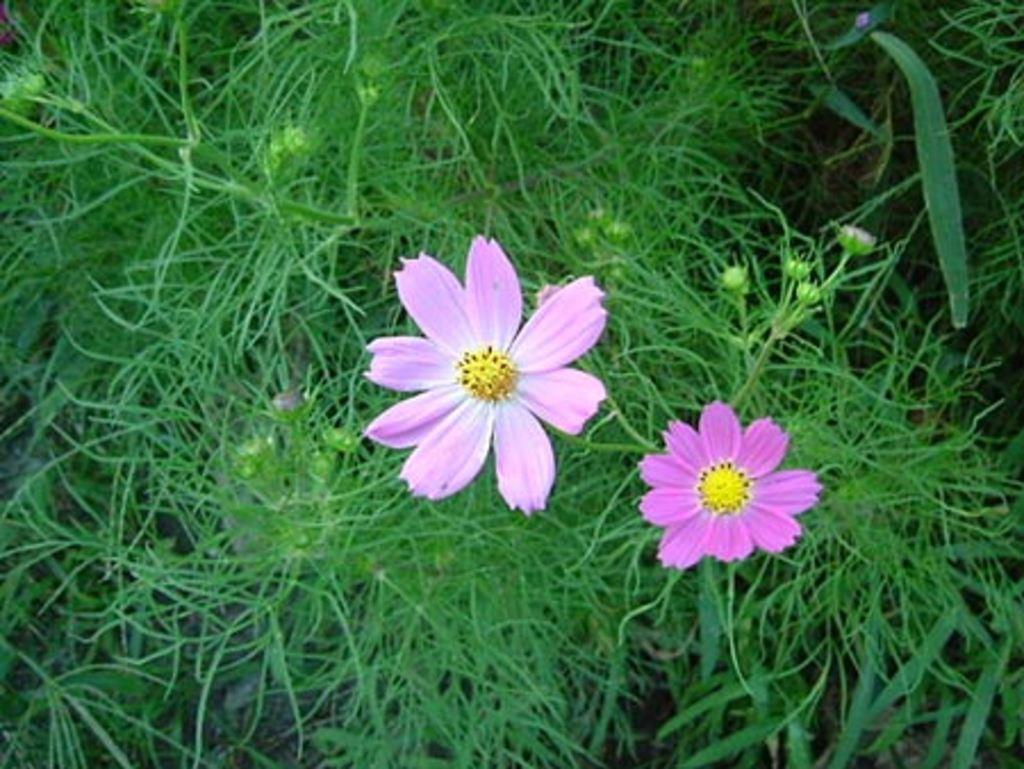What type of living organisms can be seen in the image? Flowers, buds, and plants can be seen in the image. Can you describe the growth stage of the plants in the image? The plants in the image have buds, which indicates they are in the process of blooming. What type of book is the rock reading in the image? There is no rock or book present in the image; it features flowers, buds, and plants. 